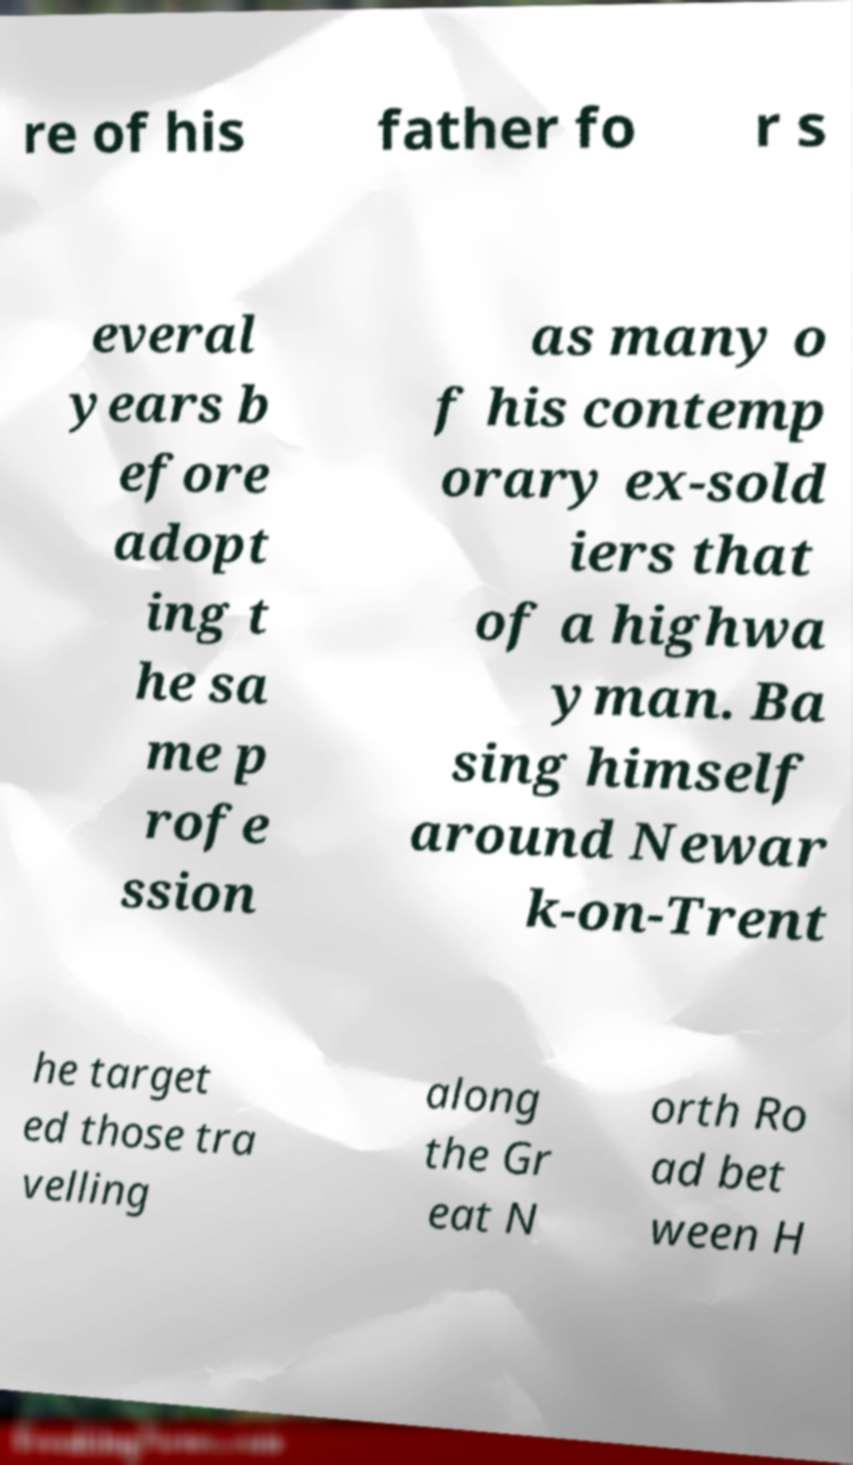Could you assist in decoding the text presented in this image and type it out clearly? re of his father fo r s everal years b efore adopt ing t he sa me p rofe ssion as many o f his contemp orary ex-sold iers that of a highwa yman. Ba sing himself around Newar k-on-Trent he target ed those tra velling along the Gr eat N orth Ro ad bet ween H 